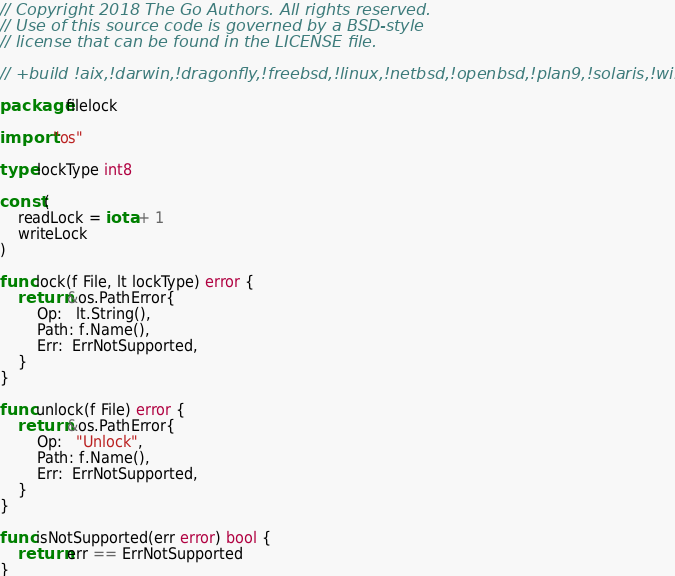<code> <loc_0><loc_0><loc_500><loc_500><_Go_>// Copyright 2018 The Go Authors. All rights reserved.
// Use of this source code is governed by a BSD-style
// license that can be found in the LICENSE file.

// +build !aix,!darwin,!dragonfly,!freebsd,!linux,!netbsd,!openbsd,!plan9,!solaris,!windows,!js

package filelock

import "os"

type lockType int8

const (
	readLock = iota + 1
	writeLock
)

func lock(f File, lt lockType) error {
	return &os.PathError{
		Op:   lt.String(),
		Path: f.Name(),
		Err:  ErrNotSupported,
	}
}

func unlock(f File) error {
	return &os.PathError{
		Op:   "Unlock",
		Path: f.Name(),
		Err:  ErrNotSupported,
	}
}

func isNotSupported(err error) bool {
	return err == ErrNotSupported
}
</code> 